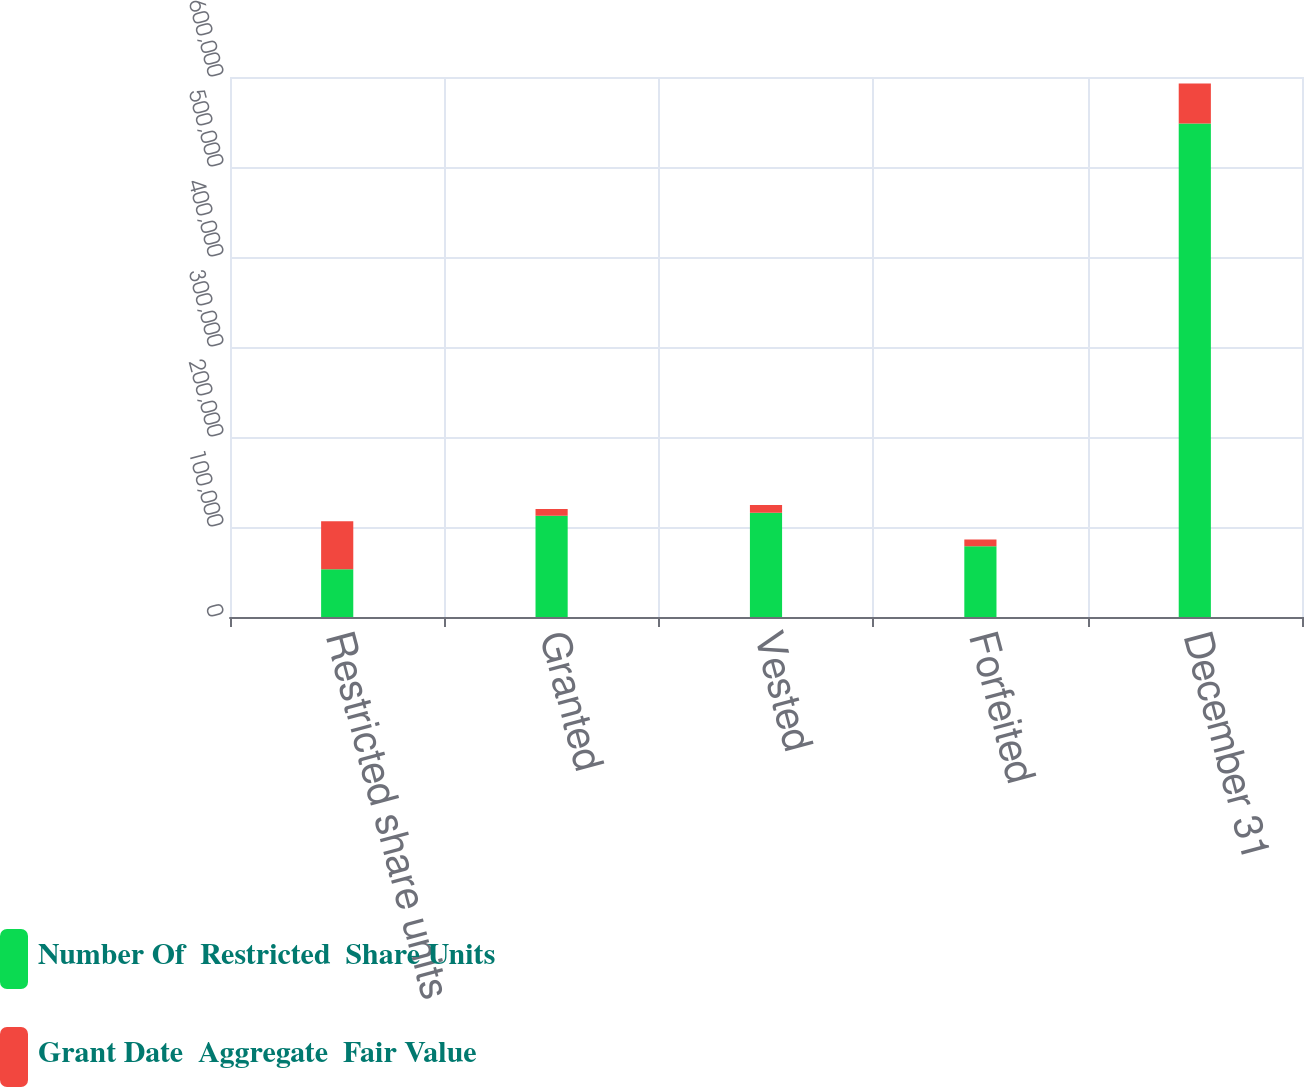Convert chart. <chart><loc_0><loc_0><loc_500><loc_500><stacked_bar_chart><ecel><fcel>Restricted share units<fcel>Granted<fcel>Vested<fcel>Forfeited<fcel>December 31<nl><fcel>Number Of  Restricted  Share Units<fcel>53132<fcel>112550<fcel>115723<fcel>78685<fcel>548354<nl><fcel>Grant Date  Aggregate  Fair Value<fcel>53132<fcel>7428<fcel>8783<fcel>7465<fcel>44312<nl></chart> 